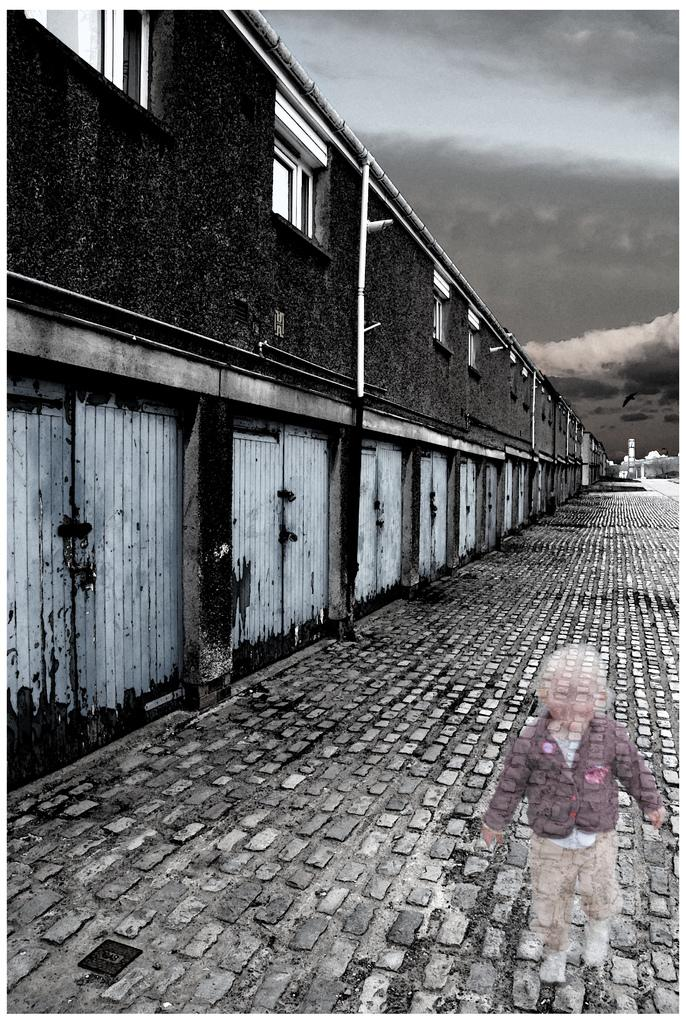What type of structures can be seen in the image? There are buildings in the image. How many doors are visible in the image? There are multiple doors visible in the image. Can you describe the child in the image? There is a child in the image. What is the condition of the sky in the background? The sky is cloudy in the background. What type of wound can be seen on the child's forehead in the image? There is no wound visible on the child's forehead in the image. 